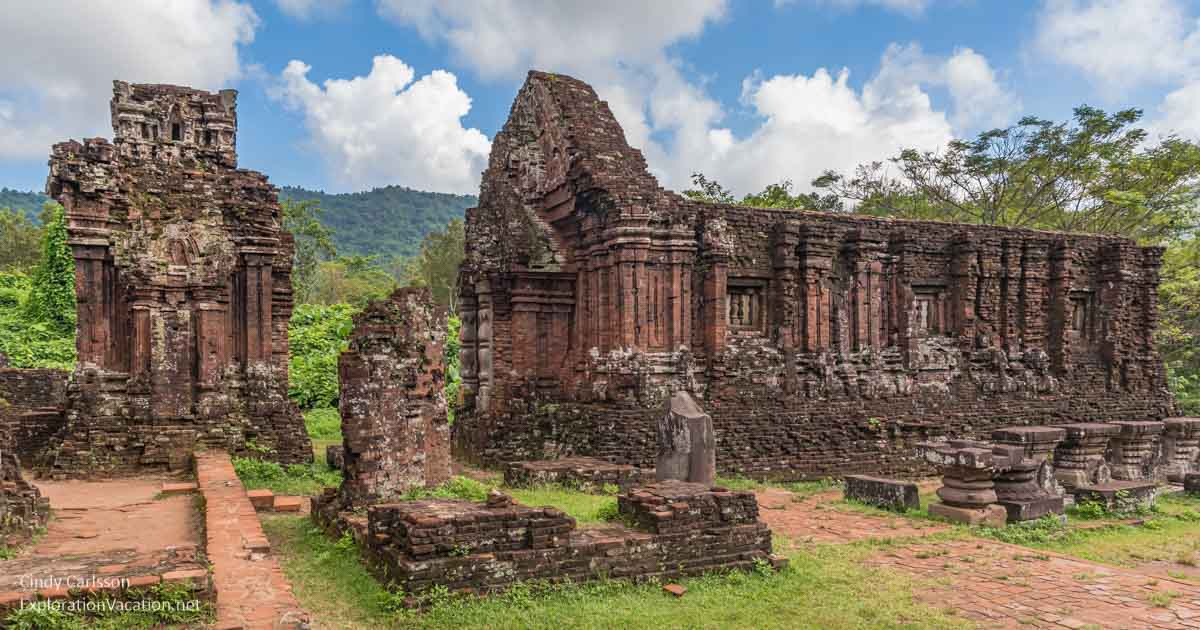Can you describe what the original construction techniques for these temples might have involved? The construction of the My Son temples involved advanced techniques that were remarkable for their time, including the use of red bricks and a special type of mortar made from tree resin and other organic materials, which has baffled researchers with its effectiveness and durability. The bricks were laid without the use of mortar in some cases, with a precision that allowed them to interlock tightly. The temples also feature intricate bas-reliefs and sculptures, which required skilled craftsmanship and knowledge of both artistic and structural principles. 